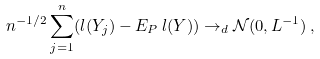Convert formula to latex. <formula><loc_0><loc_0><loc_500><loc_500>n ^ { - 1 / 2 } \sum _ { j = 1 } ^ { n } ( l ( Y _ { j } ) - E _ { P } \, l ( Y ) ) \rightarrow _ { d } \mathcal { N } ( 0 , L ^ { - 1 } ) \, ,</formula> 